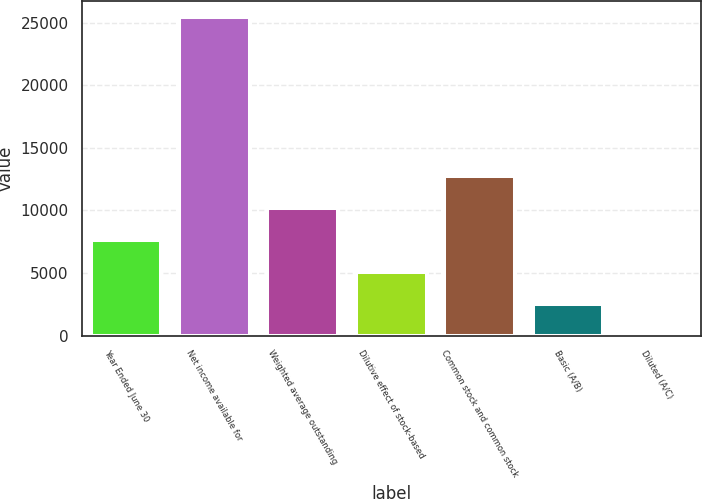<chart> <loc_0><loc_0><loc_500><loc_500><bar_chart><fcel>Year Ended June 30<fcel>Net income available for<fcel>Weighted average outstanding<fcel>Dilutive effect of stock-based<fcel>Common stock and common stock<fcel>Basic (A/B)<fcel>Diluted (A/C)<nl><fcel>7648.99<fcel>25489<fcel>10197.6<fcel>5100.41<fcel>12746.1<fcel>2551.83<fcel>3.25<nl></chart> 